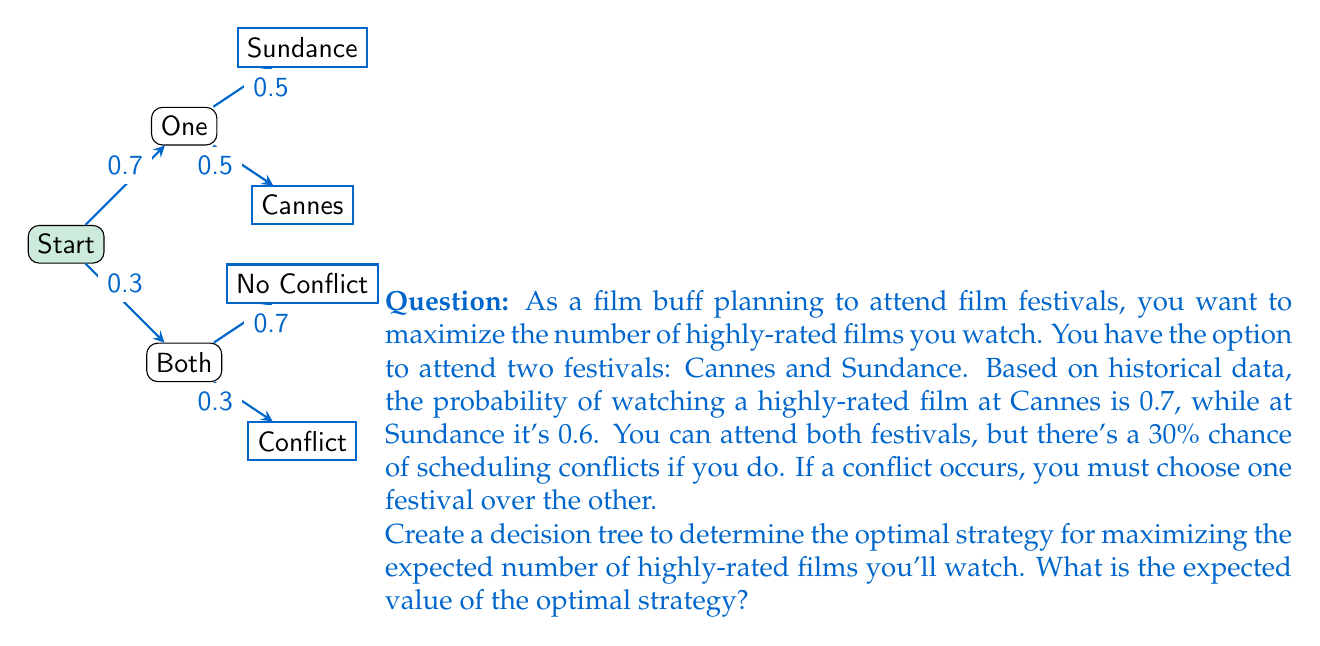What is the answer to this math problem? Let's approach this step-by-step:

1) First, let's calculate the expected value for each end node:

   - Both festivals with no conflict: $0.7 + 0.6 = 1.3$ highly-rated films
   - Conflict, choose Cannes: $0.7$ highly-rated films
   - Conflict, choose Sundance: $0.6$ highly-rated films
   - Only Cannes: $0.7$ highly-rated films
   - Only Sundance: $0.6$ highly-rated films

2) Now, let's work backwards through the decision tree:

   a) In case of a conflict when attending both festivals, we would choose Cannes as it has a higher probability (0.7 > 0.6).

   b) For the "Both" branch:
      Expected value = $(0.3 * 0.7) + (0.7 * 1.3) = 0.21 + 0.91 = 1.12$

   c) For the "One" branch:
      Cannes (0.7) is better than Sundance (0.6), so we would choose Cannes.

3) At the root decision node, we compare:
   - Attending both: 1.12 highly-rated films
   - Attending only Cannes: 0.7 highly-rated films

4) The optimal strategy is to plan to attend both festivals, as it yields a higher expected value.

Therefore, the expected value of the optimal strategy is 1.12 highly-rated films.
Answer: 1.12 highly-rated films 